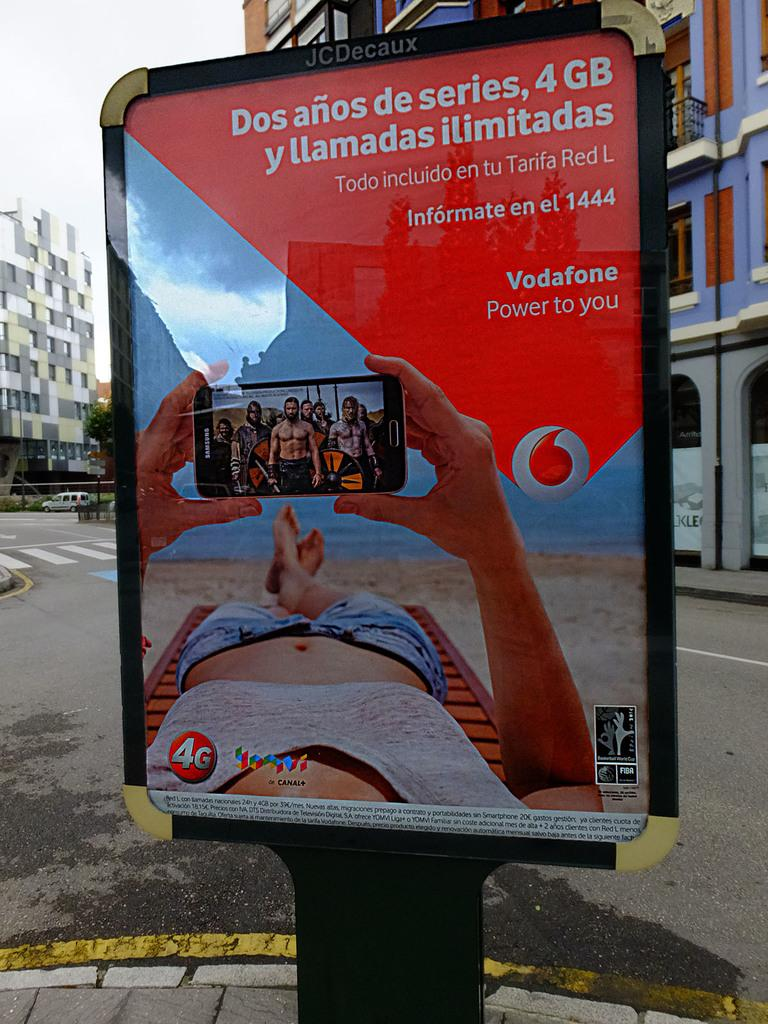Provide a one-sentence caption for the provided image. Vodafone has placed a street ad in Spanish advertising a two year deal of unlimited calls and 4G service. 